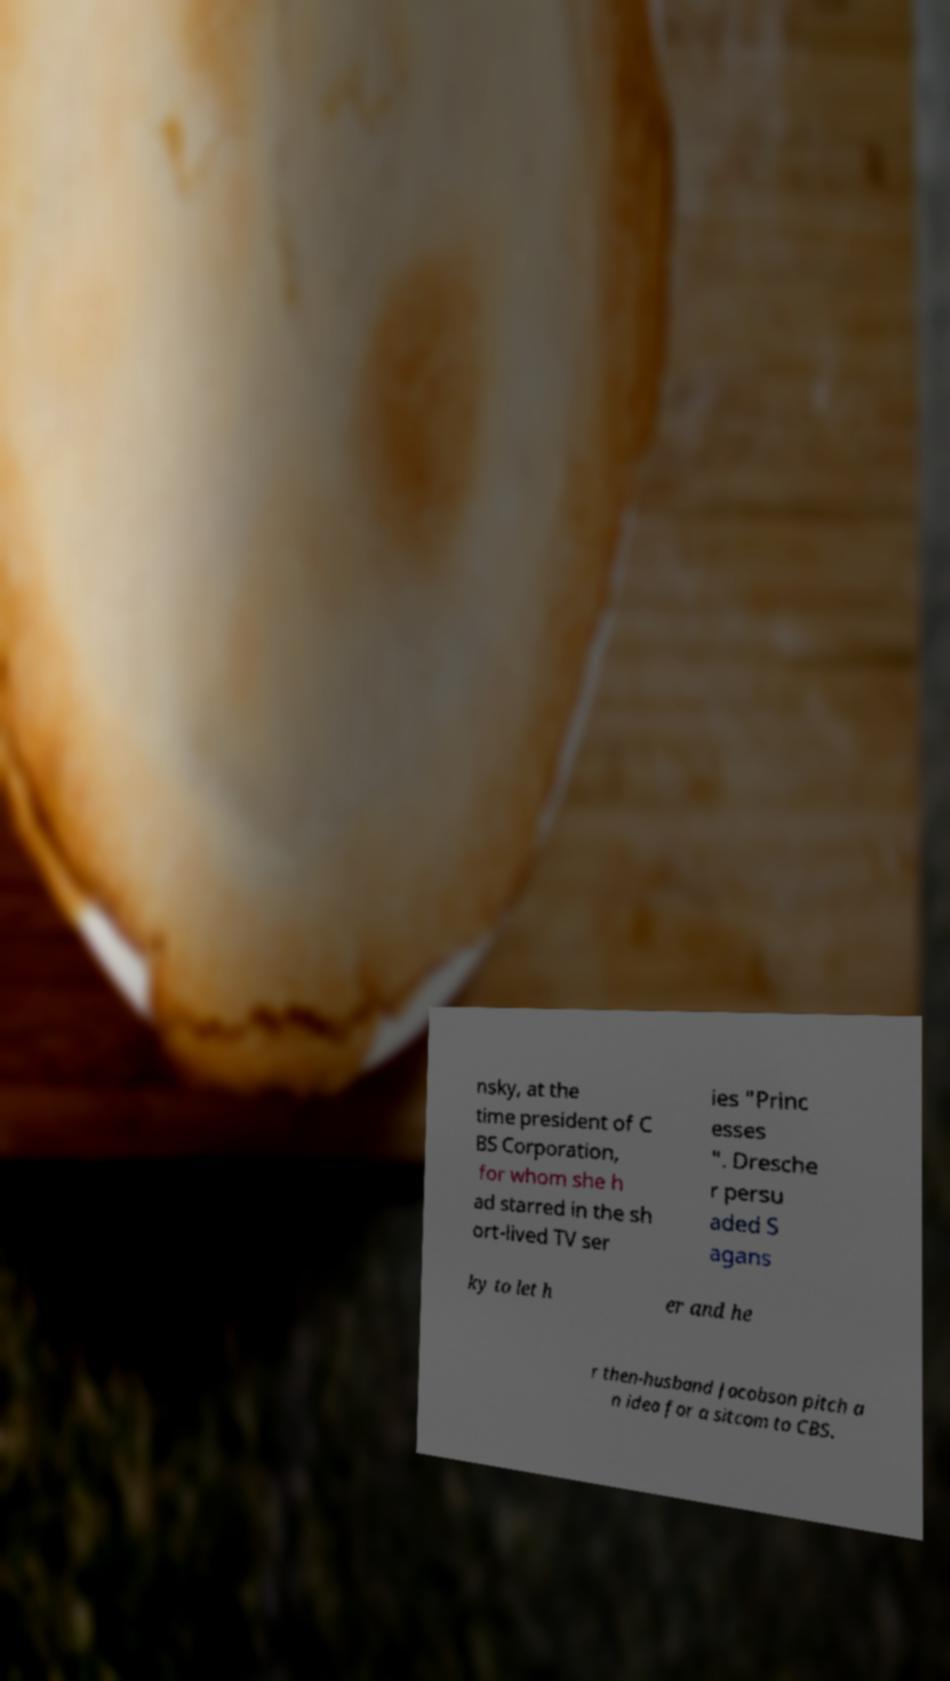Could you assist in decoding the text presented in this image and type it out clearly? nsky, at the time president of C BS Corporation, for whom she h ad starred in the sh ort-lived TV ser ies "Princ esses ". Dresche r persu aded S agans ky to let h er and he r then-husband Jacobson pitch a n idea for a sitcom to CBS. 